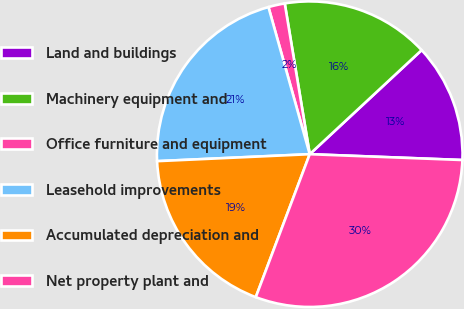Convert chart. <chart><loc_0><loc_0><loc_500><loc_500><pie_chart><fcel>Land and buildings<fcel>Machinery equipment and<fcel>Office furniture and equipment<fcel>Leasehold improvements<fcel>Accumulated depreciation and<fcel>Net property plant and<nl><fcel>12.53%<fcel>15.69%<fcel>1.74%<fcel>21.37%<fcel>18.53%<fcel>30.13%<nl></chart> 